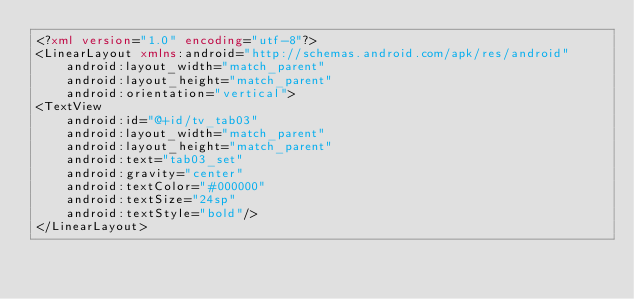Convert code to text. <code><loc_0><loc_0><loc_500><loc_500><_XML_><?xml version="1.0" encoding="utf-8"?>
<LinearLayout xmlns:android="http://schemas.android.com/apk/res/android"
    android:layout_width="match_parent"
    android:layout_height="match_parent"
    android:orientation="vertical">
<TextView
    android:id="@+id/tv_tab03"
    android:layout_width="match_parent"
    android:layout_height="match_parent"
    android:text="tab03_set"
    android:gravity="center"
    android:textColor="#000000"
    android:textSize="24sp"
    android:textStyle="bold"/>
</LinearLayout>
</code> 